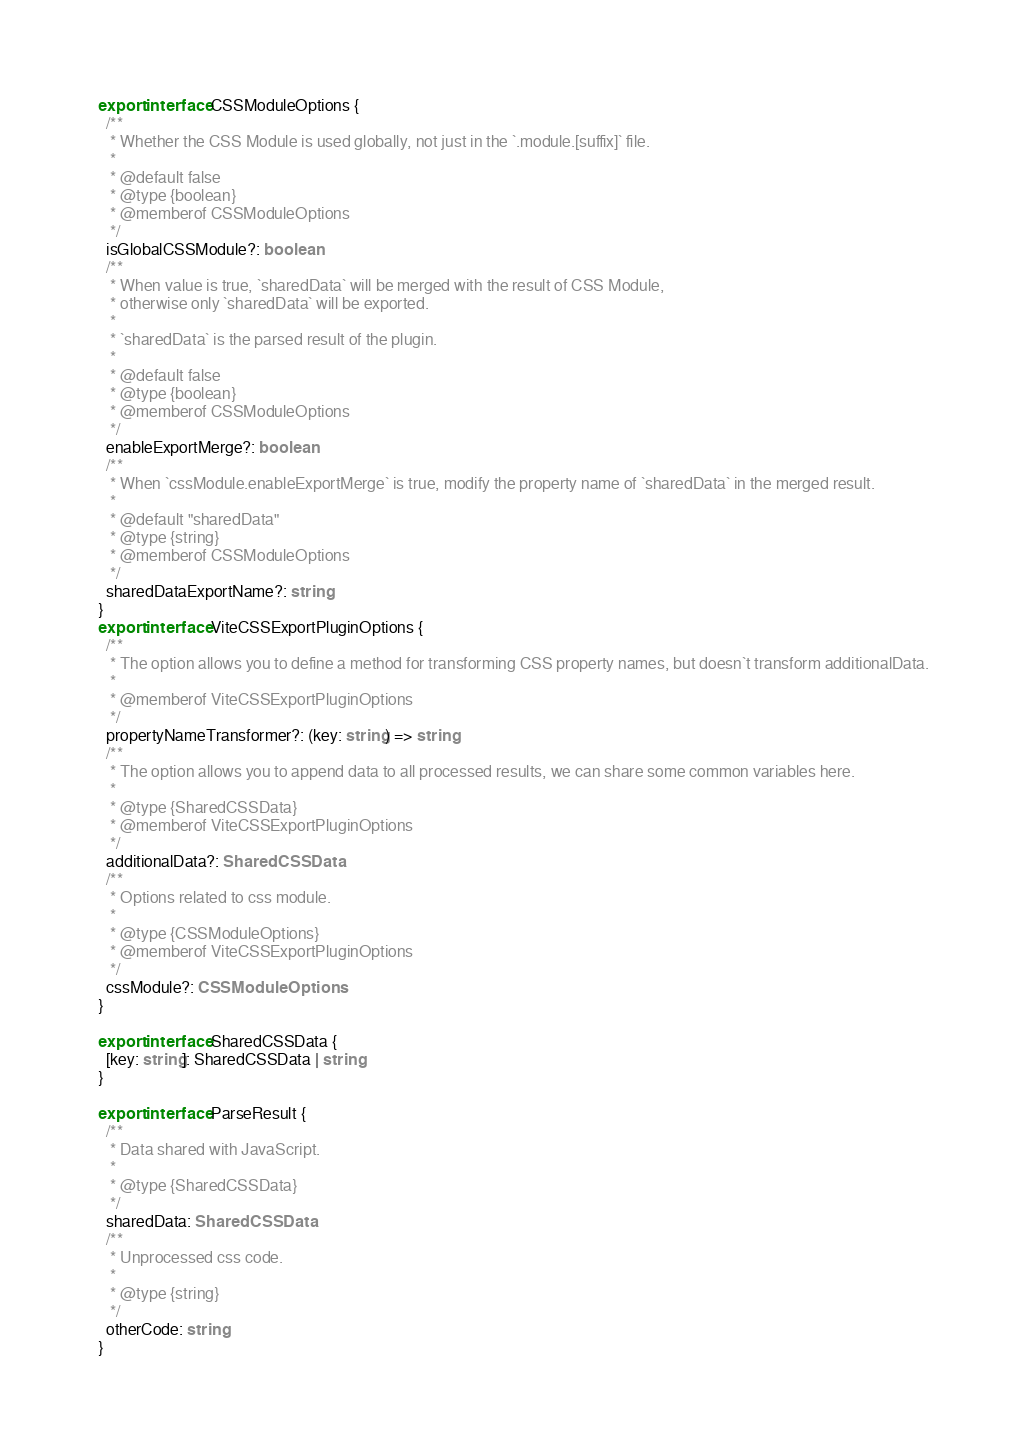<code> <loc_0><loc_0><loc_500><loc_500><_TypeScript_>export interface CSSModuleOptions {
  /**
   * Whether the CSS Module is used globally, not just in the `.module.[suffix]` file.
   *
   * @default false
   * @type {boolean}
   * @memberof CSSModuleOptions
   */
  isGlobalCSSModule?: boolean
  /**
   * When value is true, `sharedData` will be merged with the result of CSS Module,
   * otherwise only `sharedData` will be exported.
   *
   * `sharedData` is the parsed result of the plugin.
   *
   * @default false
   * @type {boolean}
   * @memberof CSSModuleOptions
   */
  enableExportMerge?: boolean
  /**
   * When `cssModule.enableExportMerge` is true, modify the property name of `sharedData` in the merged result.
   *
   * @default "sharedData"
   * @type {string}
   * @memberof CSSModuleOptions
   */
  sharedDataExportName?: string
}
export interface ViteCSSExportPluginOptions {
  /**
   * The option allows you to define a method for transforming CSS property names, but doesn`t transform additionalData.
   *
   * @memberof ViteCSSExportPluginOptions
   */
  propertyNameTransformer?: (key: string) => string
  /**
   * The option allows you to append data to all processed results, we can share some common variables here.
   *
   * @type {SharedCSSData}
   * @memberof ViteCSSExportPluginOptions
   */
  additionalData?: SharedCSSData
  /**
   * Options related to css module.
   * 
   * @type {CSSModuleOptions}
   * @memberof ViteCSSExportPluginOptions
   */
  cssModule?: CSSModuleOptions
}

export interface SharedCSSData {
  [key: string]: SharedCSSData | string
}

export interface ParseResult {
  /**
   * Data shared with JavaScript.
   *
   * @type {SharedCSSData}
   */
  sharedData: SharedCSSData
  /**
   * Unprocessed css code.
   *
   * @type {string}
   */
  otherCode: string
}
</code> 